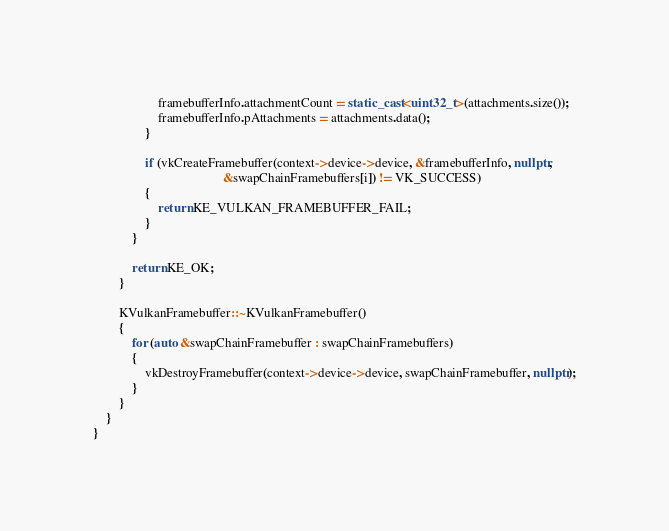Convert code to text. <code><loc_0><loc_0><loc_500><loc_500><_C++_>					framebufferInfo.attachmentCount = static_cast<uint32_t>(attachments.size());
					framebufferInfo.pAttachments = attachments.data();
				}

				if (vkCreateFramebuffer(context->device->device, &framebufferInfo, nullptr,
				                        &swapChainFramebuffers[i]) != VK_SUCCESS)
				{
					return KE_VULKAN_FRAMEBUFFER_FAIL;
				}
			}

			return KE_OK;
		}

		KVulkanFramebuffer::~KVulkanFramebuffer()
		{
			for (auto &swapChainFramebuffer : swapChainFramebuffers)
			{
				vkDestroyFramebuffer(context->device->device, swapChainFramebuffer, nullptr);
			}
		}
	}
}
</code> 